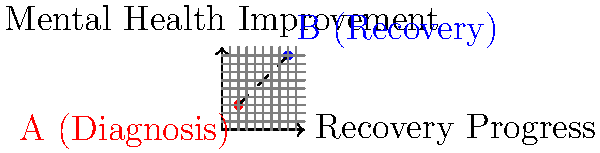On a graph representing a patient's mental health journey, point A(2,3) represents the initial diagnosis, and point B(8,9) represents the current recovery state. Calculate the distance between these two points to quantify the progress made in the patient's recovery. Round your answer to two decimal places. To calculate the distance between two points on a coordinate plane, we use the distance formula:

$$d = \sqrt{(x_2 - x_1)^2 + (y_2 - y_1)^2}$$

Where $(x_1, y_1)$ is the first point and $(x_2, y_2)$ is the second point.

Given:
Point A (diagnosis): $(2, 3)$
Point B (recovery): $(8, 9)$

Step 1: Identify the coordinates
$x_1 = 2$, $y_1 = 3$
$x_2 = 8$, $y_2 = 9$

Step 2: Substitute these values into the distance formula
$$d = \sqrt{(8 - 2)^2 + (9 - 3)^2}$$

Step 3: Simplify the expressions inside the parentheses
$$d = \sqrt{6^2 + 6^2}$$

Step 4: Calculate the squares
$$d = \sqrt{36 + 36}$$

Step 5: Add the values under the square root
$$d = \sqrt{72}$$

Step 6: Simplify the square root
$$d = 6\sqrt{2}$$

Step 7: Calculate the approximate value and round to two decimal places
$$d \approx 8.49$$

Therefore, the distance between the diagnosis point and the recovery point is approximately 8.49 units.
Answer: 8.49 units 